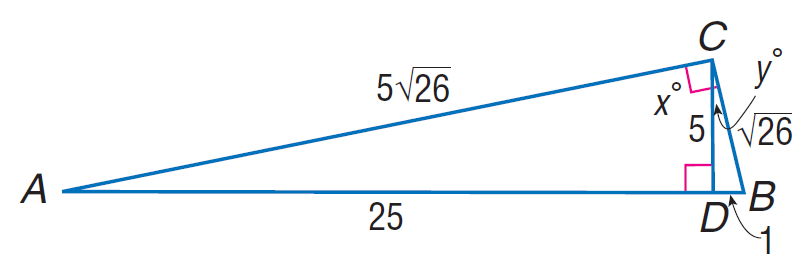Question: Find \sin A.
Choices:
A. \sqrt { 26 } / 26
B. \sqrt { 26 } / 22
C. \sqrt { 26 } / 5
D. \sqrt { 26 } / 3
Answer with the letter. Answer: A Question: Find \tan B.
Choices:
A. 3
B. 5
C. 8
D. 10
Answer with the letter. Answer: B Question: Find \cos A.
Choices:
A. \frac { \sqrt { 26 } } { 26 }
B. \frac { 2 \sqrt { 26 } } { 26 }
C. \frac { 5 \sqrt { 26 } } { 26 }
D. \frac { 7 \sqrt { 26 } } { 26 }
Answer with the letter. Answer: C 